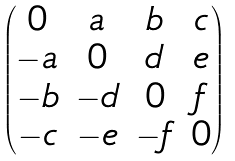<formula> <loc_0><loc_0><loc_500><loc_500>\begin{pmatrix} 0 & a & b & c \\ - a & 0 & d & e \\ - b & - d & 0 & f \\ - c & - e & - f & 0 \end{pmatrix}</formula> 